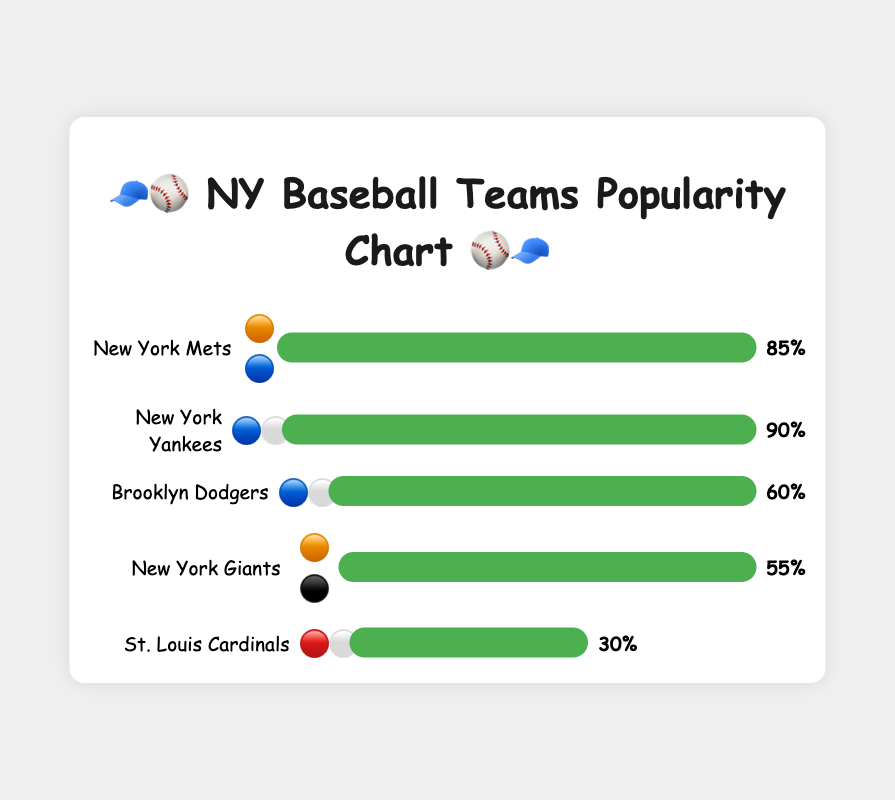Which team has the highest popularity? The chart shows each team's popularity as a bar with a percentage. The New York Yankees have the longest bar and the highest percentage at 90%.
Answer: New York Yankees Which team has the lowest popularity? By looking at the chart, the team with the shortest bar and smallest percentage is the St. Louis Cardinals at 30%.
Answer: St. Louis Cardinals How much more popular are the New York Yankees compared to the St. Louis Cardinals? Subtract the popularity of the St. Louis Cardinals (30%) from the popularity of the New York Yankees (90%): 90% - 30% = 60%.
Answer: 60% Compare the emoji representations of the New York Mets and the New York Yankee. What are their similarities and differences? The New York Mets' emoji is 🟠🔵 (orange and blue) while the New York Yankees' emoji is 🔵⚪ (blue and white). Both include blue but differ in their second color.
Answer: Similarity: Both include blue. Difference: Mets have orange, Yankees have white Which team is represented by both orange and black emojis and what is its popularity? By identifying the emoji, the New York Giants are represented by 🟠⚫ and have a popularity of 55%.
Answer: New York Giants, 55% What is the combined popularity of the New York Mets and the Brooklyn Dodgers? Sum the popularity percentages of the New York Mets (85%) and the Brooklyn Dodgers (60%): 85% + 60% = 145%.
Answer: 145% How many teams have a popularity of over 50%? Checking the percentages visually, the New York Mets (85%), New York Yankees (90%), Brooklyn Dodgers (60%), and New York Giants (55%) all have over 50%. This totals 4 teams.
Answer: 4 Is the popularity of the Brooklyn Dodgers higher or lower than the New York Giants? Comparing the bars, the Brooklyn Dodgers have a popularity of 60% while the New York Giants have 55%, so the Dodgers are higher.
Answer: Higher Which teams have an emoji with the color blue? By identifying the emojis with blue, the teams are New York Mets (🟠🔵), New York Yankees (🔵⚪), and Brooklyn Dodgers (🔵⚪).
Answer: New York Mets, New York Yankees, Brooklyn Dodgers 